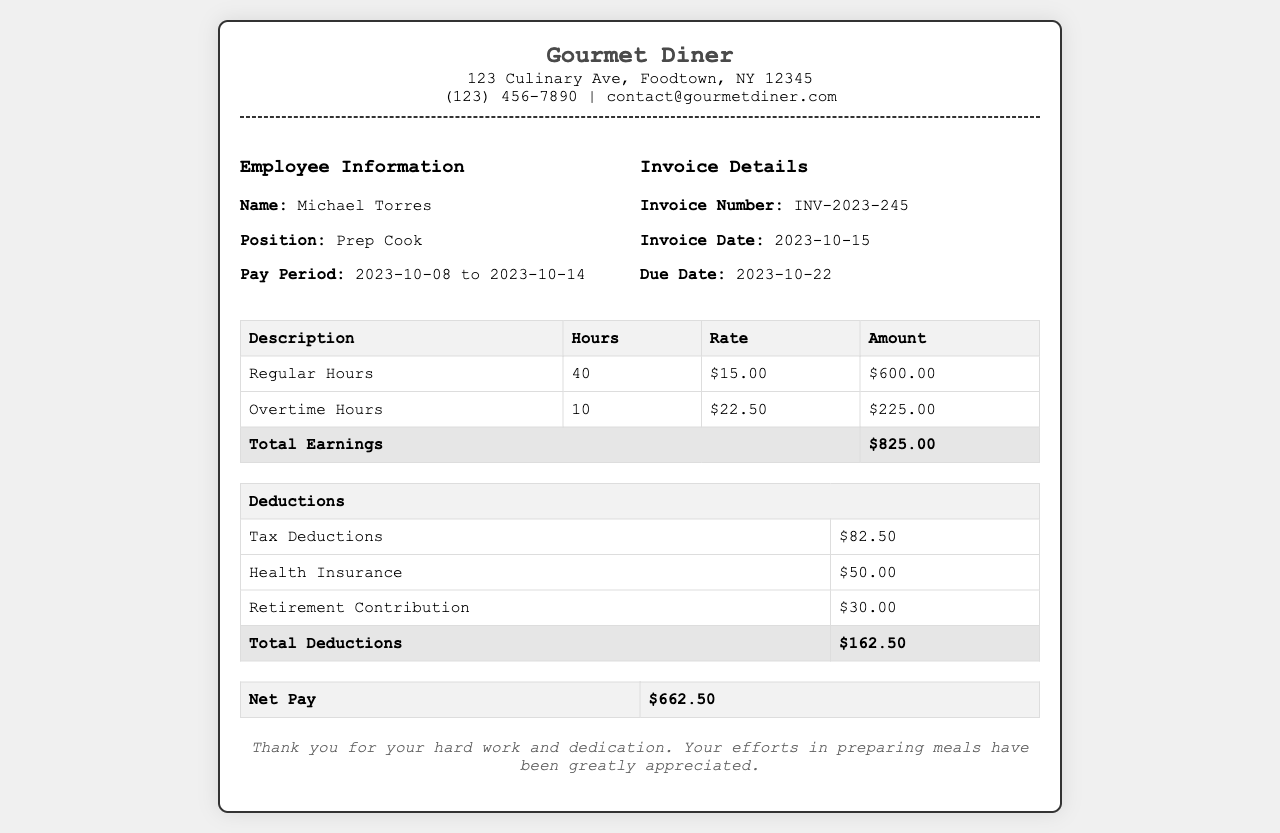What is the total earnings for the week? Total earnings are calculated by adding regular and overtime hours worked multiplied by their respective rates, which is $600.00 + $225.00 = $825.00.
Answer: $825.00 What are the total deductions? Total deductions are the sum of tax deductions, health insurance, and retirement contribution, which totals $82.50 + $50.00 + $30.00 = $162.50.
Answer: $162.50 What is the net pay amount? Net pay is calculated by subtracting total deductions from total earnings, which is $825.00 - $162.50 = $662.50.
Answer: $662.50 What is the employee's position? The position of the employee is listed in the document under employee information as "Prep Cook."
Answer: Prep Cook What is the pay period for this invoice? The pay period is indicated in the document as the range from October 8 to October 14, 2023.
Answer: 2023-10-08 to 2023-10-14 How many overtime hours were worked? Overtime hours worked are provided in the document as 10 hours.
Answer: 10 What is the rate for regular hours? The rate for regular hours is specified as $15.00 per hour in the earnings table.
Answer: $15.00 What is the tax deduction amount? The tax deduction amount is explicitly stated in the deductions table as $82.50.
Answer: $82.50 What is the due date for the invoice? The due date for the invoice is highlighted in the invoice details as October 22, 2023.
Answer: 2023-10-22 